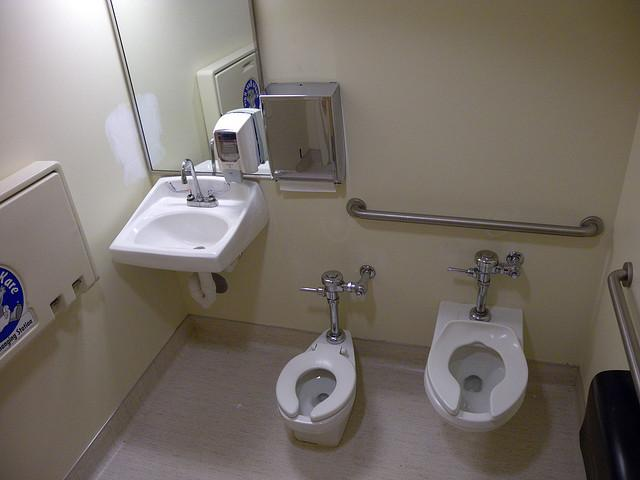How many items appear to be made of porcelain? three 